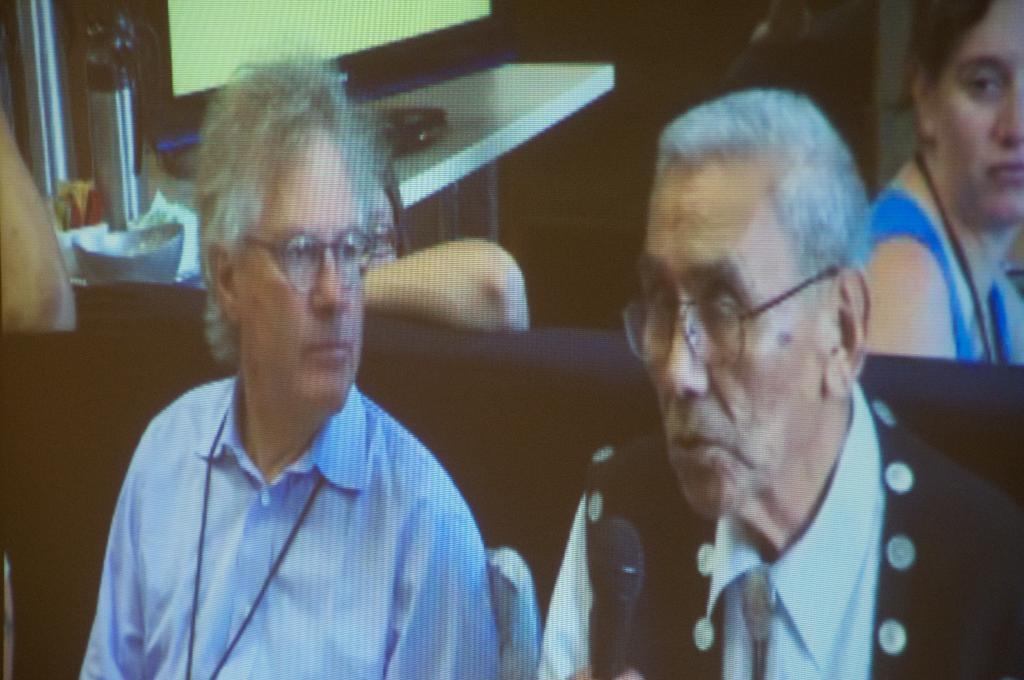How would you summarize this image in a sentence or two? In this image, there are two persons wearing clothes and spectacles. There is an another person in the top right of the image. There is a table in the top left of the image contains a monitor. 